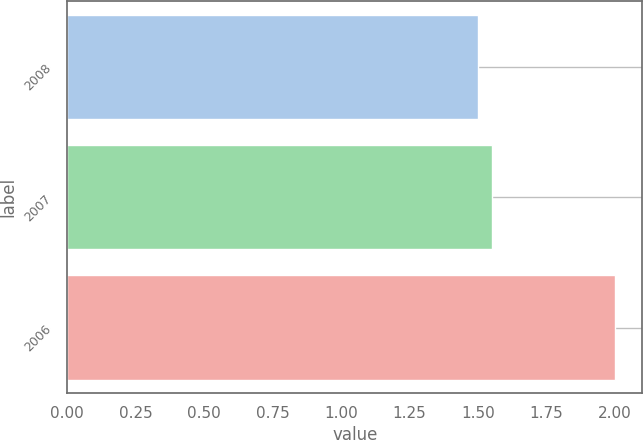<chart> <loc_0><loc_0><loc_500><loc_500><bar_chart><fcel>2008<fcel>2007<fcel>2006<nl><fcel>1.5<fcel>1.55<fcel>2<nl></chart> 